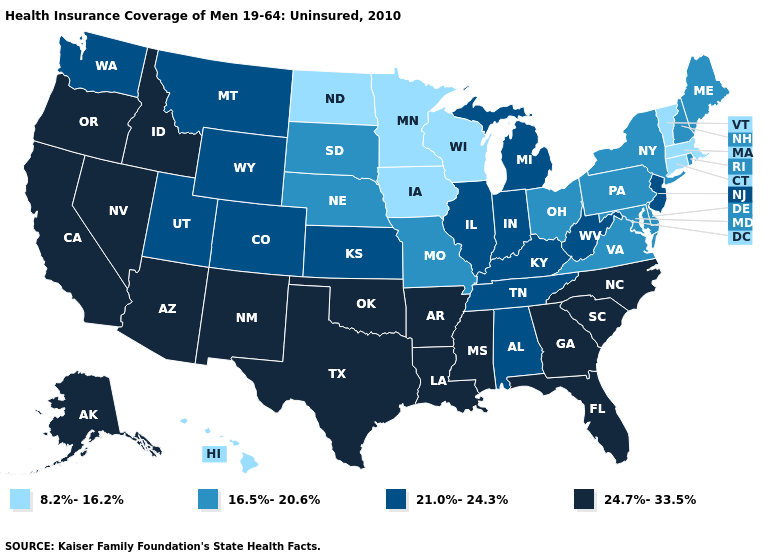Which states hav the highest value in the Northeast?
Write a very short answer. New Jersey. Which states have the lowest value in the USA?
Concise answer only. Connecticut, Hawaii, Iowa, Massachusetts, Minnesota, North Dakota, Vermont, Wisconsin. Does Tennessee have the highest value in the USA?
Quick response, please. No. Name the states that have a value in the range 16.5%-20.6%?
Short answer required. Delaware, Maine, Maryland, Missouri, Nebraska, New Hampshire, New York, Ohio, Pennsylvania, Rhode Island, South Dakota, Virginia. What is the lowest value in the USA?
Concise answer only. 8.2%-16.2%. Does Nebraska have the lowest value in the MidWest?
Give a very brief answer. No. What is the highest value in the Northeast ?
Quick response, please. 21.0%-24.3%. Name the states that have a value in the range 8.2%-16.2%?
Answer briefly. Connecticut, Hawaii, Iowa, Massachusetts, Minnesota, North Dakota, Vermont, Wisconsin. Name the states that have a value in the range 8.2%-16.2%?
Give a very brief answer. Connecticut, Hawaii, Iowa, Massachusetts, Minnesota, North Dakota, Vermont, Wisconsin. Name the states that have a value in the range 8.2%-16.2%?
Keep it brief. Connecticut, Hawaii, Iowa, Massachusetts, Minnesota, North Dakota, Vermont, Wisconsin. Does the map have missing data?
Concise answer only. No. Which states have the highest value in the USA?
Write a very short answer. Alaska, Arizona, Arkansas, California, Florida, Georgia, Idaho, Louisiana, Mississippi, Nevada, New Mexico, North Carolina, Oklahoma, Oregon, South Carolina, Texas. What is the value of Massachusetts?
Short answer required. 8.2%-16.2%. Name the states that have a value in the range 21.0%-24.3%?
Keep it brief. Alabama, Colorado, Illinois, Indiana, Kansas, Kentucky, Michigan, Montana, New Jersey, Tennessee, Utah, Washington, West Virginia, Wyoming. Does New Jersey have the highest value in the Northeast?
Answer briefly. Yes. 